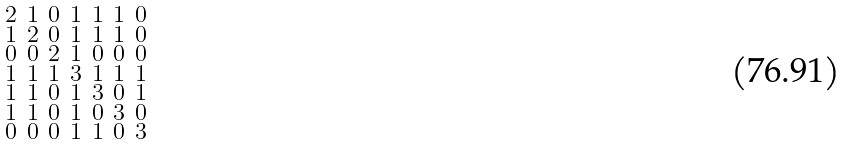Convert formula to latex. <formula><loc_0><loc_0><loc_500><loc_500>\begin{smallmatrix} 2 & 1 & 0 & 1 & 1 & 1 & 0 \\ 1 & 2 & 0 & 1 & 1 & 1 & 0 \\ 0 & 0 & 2 & 1 & 0 & 0 & 0 \\ 1 & 1 & 1 & 3 & 1 & 1 & 1 \\ 1 & 1 & 0 & 1 & 3 & 0 & 1 \\ 1 & 1 & 0 & 1 & 0 & 3 & 0 \\ 0 & 0 & 0 & 1 & 1 & 0 & 3 \end{smallmatrix}</formula> 